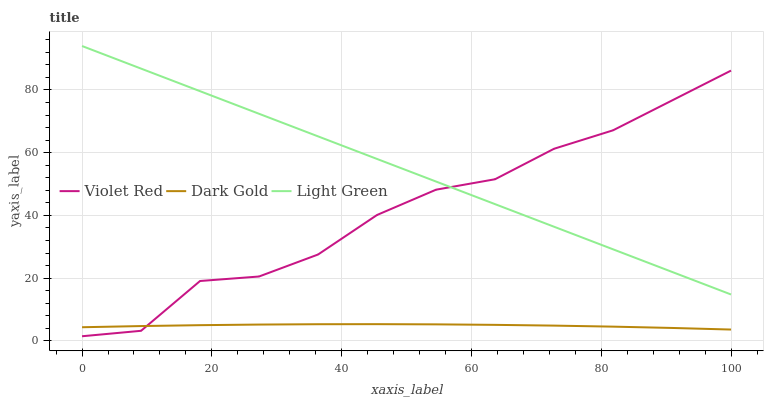Does Dark Gold have the minimum area under the curve?
Answer yes or no. Yes. Does Light Green have the maximum area under the curve?
Answer yes or no. Yes. Does Light Green have the minimum area under the curve?
Answer yes or no. No. Does Dark Gold have the maximum area under the curve?
Answer yes or no. No. Is Light Green the smoothest?
Answer yes or no. Yes. Is Violet Red the roughest?
Answer yes or no. Yes. Is Dark Gold the smoothest?
Answer yes or no. No. Is Dark Gold the roughest?
Answer yes or no. No. Does Dark Gold have the lowest value?
Answer yes or no. No. Does Light Green have the highest value?
Answer yes or no. Yes. Does Dark Gold have the highest value?
Answer yes or no. No. Is Dark Gold less than Light Green?
Answer yes or no. Yes. Is Light Green greater than Dark Gold?
Answer yes or no. Yes. Does Light Green intersect Violet Red?
Answer yes or no. Yes. Is Light Green less than Violet Red?
Answer yes or no. No. Is Light Green greater than Violet Red?
Answer yes or no. No. Does Dark Gold intersect Light Green?
Answer yes or no. No. 